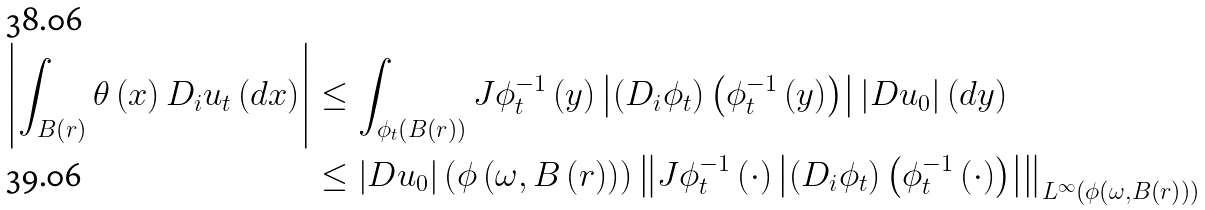<formula> <loc_0><loc_0><loc_500><loc_500>\left | \int _ { B \left ( r \right ) } \theta \left ( x \right ) D _ { i } u _ { t } \left ( d x \right ) \right | & \leq \int _ { \phi _ { t } \left ( B \left ( r \right ) \right ) } J \phi _ { t } ^ { - 1 } \left ( y \right ) \left | \left ( D _ { i } \phi _ { t } \right ) \left ( \phi _ { t } ^ { - 1 } \left ( y \right ) \right ) \right | \left | D u _ { 0 } \right | \left ( d y \right ) \\ & \leq \left | D u _ { 0 } \right | \left ( \phi \left ( \omega , B \left ( r \right ) \right ) \right ) \left \| J \phi _ { t } ^ { - 1 } \left ( \cdot \right ) \left | \left ( D _ { i } \phi _ { t } \right ) \left ( \phi _ { t } ^ { - 1 } \left ( \cdot \right ) \right ) \right | \right \| _ { L ^ { \infty } \left ( \phi \left ( \omega , B \left ( r \right ) \right ) \right ) }</formula> 